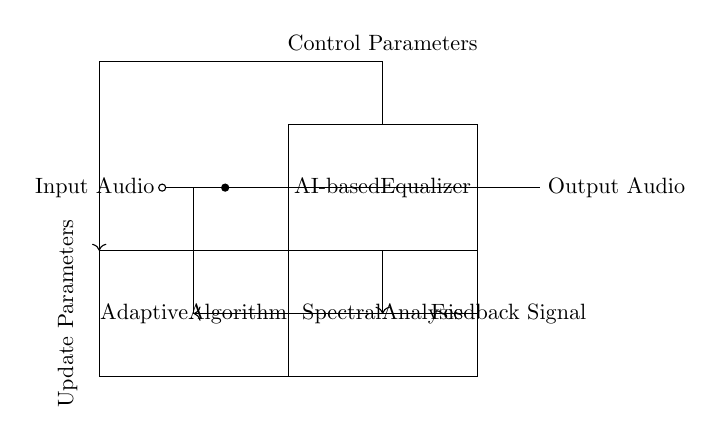What is the main function of the AI-based Equalizer? The AI-based Equalizer's main function is to process the input audio and adaptively adjust its equalization based on spectral analysis feedback.
Answer: Adaptive equalization What component generates the feedback signal? The feedback signal is generated from the output audio and is routed back into the adaptive algorithm.
Answer: Output audio How many main blocks are there in the circuit diagram? There are three main blocks: the AI-based Equalizer, Spectral Analysis, and Adaptive Algorithm.
Answer: Three What does the feedback loop do? The feedback loop connects the output audio back to the input of the adaptive algorithm, allowing for real-time adjustments based on the audio output.
Answer: Real-time adjustments What do the control parameters affect? The control parameters affect the updating of parameters for the adaptive algorithm, guiding how the equalization adapts to the audio signal.
Answer: Update parameters What type of circuit does this represent? This represents a feedback control system specifically designed for audio processing and equalization.
Answer: Feedback control system 